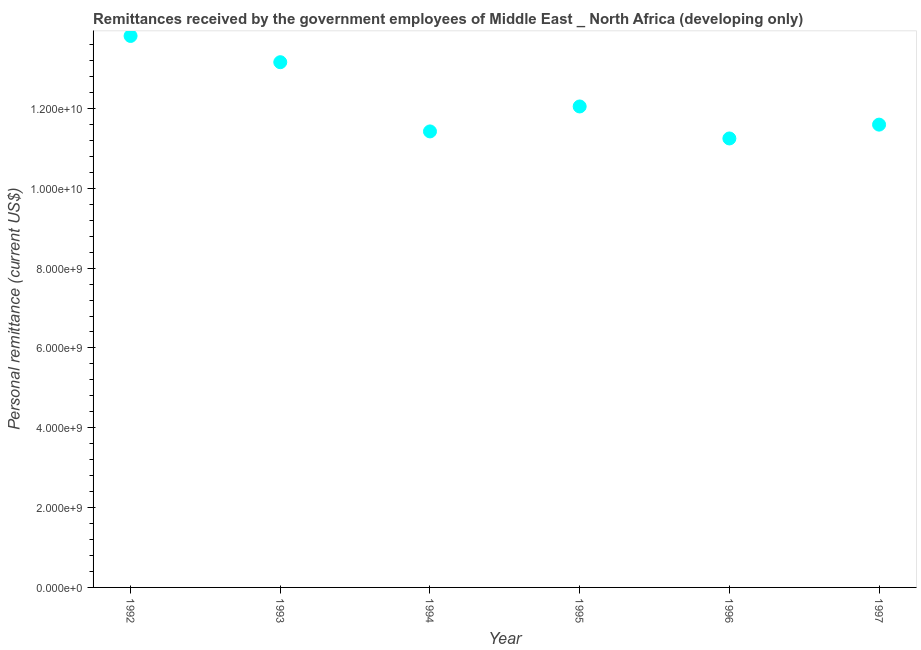What is the personal remittances in 1997?
Keep it short and to the point. 1.16e+1. Across all years, what is the maximum personal remittances?
Offer a very short reply. 1.38e+1. Across all years, what is the minimum personal remittances?
Make the answer very short. 1.12e+1. What is the sum of the personal remittances?
Your response must be concise. 7.33e+1. What is the difference between the personal remittances in 1994 and 1996?
Keep it short and to the point. 1.76e+08. What is the average personal remittances per year?
Keep it short and to the point. 1.22e+1. What is the median personal remittances?
Give a very brief answer. 1.18e+1. What is the ratio of the personal remittances in 1993 to that in 1997?
Provide a succinct answer. 1.13. What is the difference between the highest and the second highest personal remittances?
Your answer should be very brief. 6.58e+08. Is the sum of the personal remittances in 1993 and 1994 greater than the maximum personal remittances across all years?
Your response must be concise. Yes. What is the difference between the highest and the lowest personal remittances?
Provide a succinct answer. 2.57e+09. In how many years, is the personal remittances greater than the average personal remittances taken over all years?
Provide a succinct answer. 2. Does the personal remittances monotonically increase over the years?
Give a very brief answer. No. How many dotlines are there?
Offer a terse response. 1. How many years are there in the graph?
Give a very brief answer. 6. Are the values on the major ticks of Y-axis written in scientific E-notation?
Give a very brief answer. Yes. Does the graph contain any zero values?
Provide a succinct answer. No. Does the graph contain grids?
Your response must be concise. No. What is the title of the graph?
Ensure brevity in your answer.  Remittances received by the government employees of Middle East _ North Africa (developing only). What is the label or title of the Y-axis?
Give a very brief answer. Personal remittance (current US$). What is the Personal remittance (current US$) in 1992?
Your answer should be compact. 1.38e+1. What is the Personal remittance (current US$) in 1993?
Ensure brevity in your answer.  1.32e+1. What is the Personal remittance (current US$) in 1994?
Offer a terse response. 1.14e+1. What is the Personal remittance (current US$) in 1995?
Your answer should be compact. 1.21e+1. What is the Personal remittance (current US$) in 1996?
Provide a succinct answer. 1.12e+1. What is the Personal remittance (current US$) in 1997?
Give a very brief answer. 1.16e+1. What is the difference between the Personal remittance (current US$) in 1992 and 1993?
Offer a very short reply. 6.58e+08. What is the difference between the Personal remittance (current US$) in 1992 and 1994?
Keep it short and to the point. 2.39e+09. What is the difference between the Personal remittance (current US$) in 1992 and 1995?
Your response must be concise. 1.77e+09. What is the difference between the Personal remittance (current US$) in 1992 and 1996?
Your answer should be very brief. 2.57e+09. What is the difference between the Personal remittance (current US$) in 1992 and 1997?
Your answer should be compact. 2.22e+09. What is the difference between the Personal remittance (current US$) in 1993 and 1994?
Your answer should be very brief. 1.73e+09. What is the difference between the Personal remittance (current US$) in 1993 and 1995?
Offer a very short reply. 1.11e+09. What is the difference between the Personal remittance (current US$) in 1993 and 1996?
Offer a very short reply. 1.91e+09. What is the difference between the Personal remittance (current US$) in 1993 and 1997?
Your response must be concise. 1.56e+09. What is the difference between the Personal remittance (current US$) in 1994 and 1995?
Keep it short and to the point. -6.25e+08. What is the difference between the Personal remittance (current US$) in 1994 and 1996?
Provide a short and direct response. 1.76e+08. What is the difference between the Personal remittance (current US$) in 1994 and 1997?
Provide a succinct answer. -1.70e+08. What is the difference between the Personal remittance (current US$) in 1995 and 1996?
Provide a short and direct response. 8.01e+08. What is the difference between the Personal remittance (current US$) in 1995 and 1997?
Provide a succinct answer. 4.55e+08. What is the difference between the Personal remittance (current US$) in 1996 and 1997?
Make the answer very short. -3.47e+08. What is the ratio of the Personal remittance (current US$) in 1992 to that in 1994?
Your answer should be compact. 1.21. What is the ratio of the Personal remittance (current US$) in 1992 to that in 1995?
Your answer should be compact. 1.15. What is the ratio of the Personal remittance (current US$) in 1992 to that in 1996?
Give a very brief answer. 1.23. What is the ratio of the Personal remittance (current US$) in 1992 to that in 1997?
Your answer should be compact. 1.19. What is the ratio of the Personal remittance (current US$) in 1993 to that in 1994?
Your answer should be compact. 1.15. What is the ratio of the Personal remittance (current US$) in 1993 to that in 1995?
Make the answer very short. 1.09. What is the ratio of the Personal remittance (current US$) in 1993 to that in 1996?
Offer a terse response. 1.17. What is the ratio of the Personal remittance (current US$) in 1993 to that in 1997?
Provide a short and direct response. 1.14. What is the ratio of the Personal remittance (current US$) in 1994 to that in 1995?
Offer a very short reply. 0.95. What is the ratio of the Personal remittance (current US$) in 1995 to that in 1996?
Your response must be concise. 1.07. What is the ratio of the Personal remittance (current US$) in 1995 to that in 1997?
Offer a terse response. 1.04. 